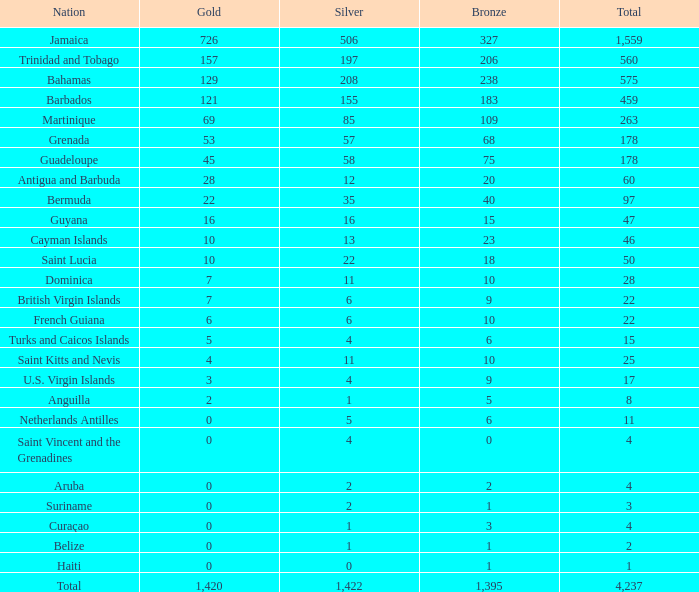What is listed as the highest Silver that also has a Gold of 4 and a Total that's larger than 25? None. 